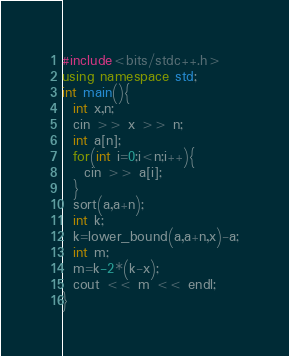Convert code to text. <code><loc_0><loc_0><loc_500><loc_500><_C++_>#include<bits/stdc++.h>
using namespace std;
int main(){
  int x,n;
  cin >> x >> n;
  int a[n];
  for(int i=0;i<n;i++){
    cin >> a[i];
  }
  sort(a,a+n);
  int k;
  k=lower_bound(a,a+n,x)-a;
  int m;
  m=k-2*(k-x);
  cout << m << endl;
}
</code> 